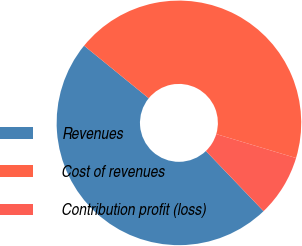Convert chart to OTSL. <chart><loc_0><loc_0><loc_500><loc_500><pie_chart><fcel>Revenues<fcel>Cost of revenues<fcel>Contribution profit (loss)<nl><fcel>48.03%<fcel>43.77%<fcel>8.2%<nl></chart> 